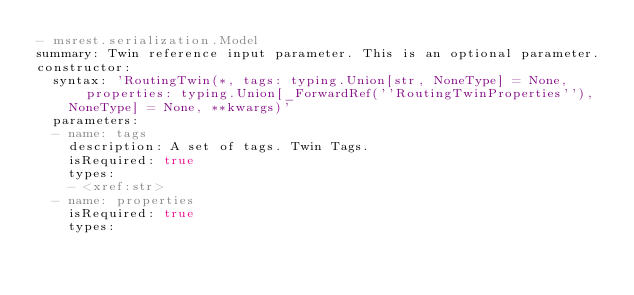Convert code to text. <code><loc_0><loc_0><loc_500><loc_500><_YAML_>- msrest.serialization.Model
summary: Twin reference input parameter. This is an optional parameter.
constructor:
  syntax: 'RoutingTwin(*, tags: typing.Union[str, NoneType] = None, properties: typing.Union[_ForwardRef(''RoutingTwinProperties''),
    NoneType] = None, **kwargs)'
  parameters:
  - name: tags
    description: A set of tags. Twin Tags.
    isRequired: true
    types:
    - <xref:str>
  - name: properties
    isRequired: true
    types:</code> 